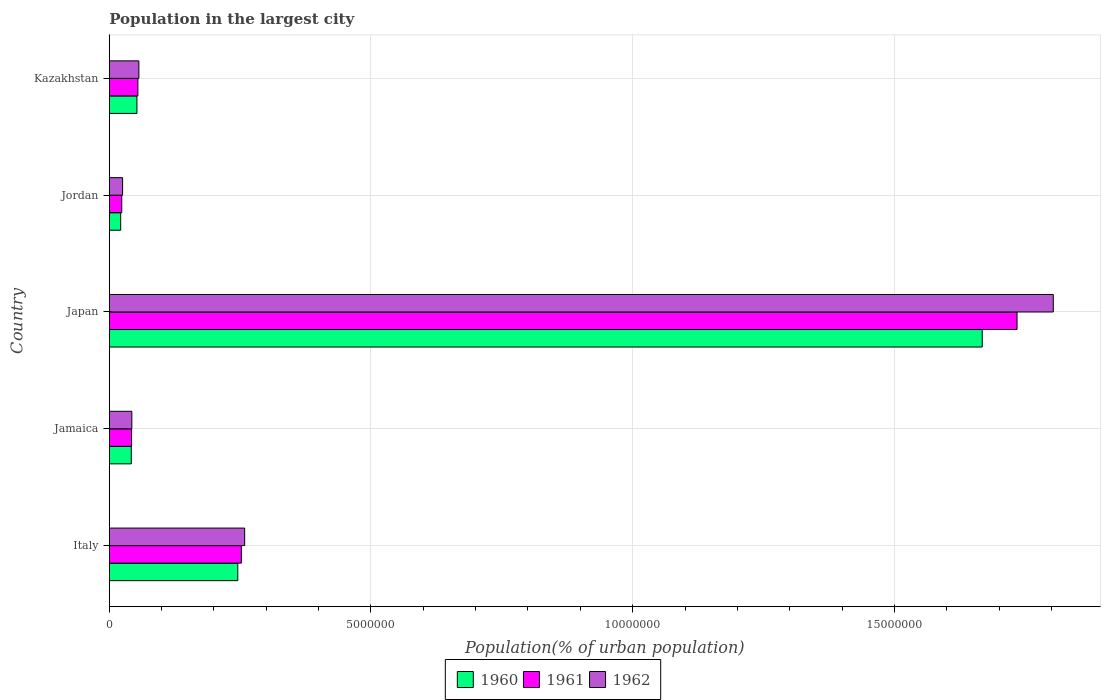How many groups of bars are there?
Give a very brief answer. 5. How many bars are there on the 5th tick from the bottom?
Provide a succinct answer. 3. What is the label of the 1st group of bars from the top?
Your response must be concise. Kazakhstan. What is the population in the largest city in 1961 in Jamaica?
Ensure brevity in your answer.  4.26e+05. Across all countries, what is the maximum population in the largest city in 1961?
Provide a short and direct response. 1.73e+07. Across all countries, what is the minimum population in the largest city in 1962?
Provide a succinct answer. 2.55e+05. In which country was the population in the largest city in 1961 minimum?
Your response must be concise. Jordan. What is the total population in the largest city in 1962 in the graph?
Offer a terse response. 2.19e+07. What is the difference between the population in the largest city in 1960 in Italy and that in Jamaica?
Provide a succinct answer. 2.03e+06. What is the difference between the population in the largest city in 1960 in Italy and the population in the largest city in 1961 in Jordan?
Keep it short and to the point. 2.22e+06. What is the average population in the largest city in 1962 per country?
Make the answer very short. 4.38e+06. What is the difference between the population in the largest city in 1961 and population in the largest city in 1960 in Italy?
Provide a short and direct response. 6.77e+04. In how many countries, is the population in the largest city in 1961 greater than 3000000 %?
Your answer should be very brief. 1. What is the ratio of the population in the largest city in 1962 in Jamaica to that in Jordan?
Your response must be concise. 1.69. Is the population in the largest city in 1962 in Italy less than that in Jordan?
Offer a very short reply. No. Is the difference between the population in the largest city in 1961 in Italy and Kazakhstan greater than the difference between the population in the largest city in 1960 in Italy and Kazakhstan?
Keep it short and to the point. Yes. What is the difference between the highest and the second highest population in the largest city in 1962?
Give a very brief answer. 1.54e+07. What is the difference between the highest and the lowest population in the largest city in 1961?
Offer a terse response. 1.71e+07. Is the sum of the population in the largest city in 1962 in Italy and Jordan greater than the maximum population in the largest city in 1960 across all countries?
Make the answer very short. No. What does the 2nd bar from the top in Japan represents?
Your answer should be very brief. 1961. Are all the bars in the graph horizontal?
Offer a terse response. Yes. Where does the legend appear in the graph?
Provide a short and direct response. Bottom center. How are the legend labels stacked?
Keep it short and to the point. Horizontal. What is the title of the graph?
Give a very brief answer. Population in the largest city. Does "1971" appear as one of the legend labels in the graph?
Provide a succinct answer. No. What is the label or title of the X-axis?
Give a very brief answer. Population(% of urban population). What is the label or title of the Y-axis?
Give a very brief answer. Country. What is the Population(% of urban population) of 1960 in Italy?
Ensure brevity in your answer.  2.46e+06. What is the Population(% of urban population) in 1961 in Italy?
Offer a very short reply. 2.52e+06. What is the Population(% of urban population) in 1962 in Italy?
Your response must be concise. 2.59e+06. What is the Population(% of urban population) of 1960 in Jamaica?
Offer a very short reply. 4.21e+05. What is the Population(% of urban population) in 1961 in Jamaica?
Give a very brief answer. 4.26e+05. What is the Population(% of urban population) in 1962 in Jamaica?
Keep it short and to the point. 4.31e+05. What is the Population(% of urban population) in 1960 in Japan?
Offer a very short reply. 1.67e+07. What is the Population(% of urban population) in 1961 in Japan?
Make the answer very short. 1.73e+07. What is the Population(% of urban population) of 1962 in Japan?
Give a very brief answer. 1.80e+07. What is the Population(% of urban population) in 1960 in Jordan?
Your answer should be compact. 2.18e+05. What is the Population(% of urban population) of 1961 in Jordan?
Your response must be concise. 2.38e+05. What is the Population(% of urban population) in 1962 in Jordan?
Ensure brevity in your answer.  2.55e+05. What is the Population(% of urban population) in 1960 in Kazakhstan?
Your answer should be compact. 5.29e+05. What is the Population(% of urban population) of 1961 in Kazakhstan?
Keep it short and to the point. 5.47e+05. What is the Population(% of urban population) in 1962 in Kazakhstan?
Give a very brief answer. 5.66e+05. Across all countries, what is the maximum Population(% of urban population) of 1960?
Offer a very short reply. 1.67e+07. Across all countries, what is the maximum Population(% of urban population) of 1961?
Keep it short and to the point. 1.73e+07. Across all countries, what is the maximum Population(% of urban population) of 1962?
Ensure brevity in your answer.  1.80e+07. Across all countries, what is the minimum Population(% of urban population) of 1960?
Your response must be concise. 2.18e+05. Across all countries, what is the minimum Population(% of urban population) in 1961?
Your answer should be compact. 2.38e+05. Across all countries, what is the minimum Population(% of urban population) of 1962?
Offer a very short reply. 2.55e+05. What is the total Population(% of urban population) in 1960 in the graph?
Provide a short and direct response. 2.03e+07. What is the total Population(% of urban population) of 1961 in the graph?
Keep it short and to the point. 2.11e+07. What is the total Population(% of urban population) of 1962 in the graph?
Provide a succinct answer. 2.19e+07. What is the difference between the Population(% of urban population) of 1960 in Italy and that in Jamaica?
Ensure brevity in your answer.  2.03e+06. What is the difference between the Population(% of urban population) of 1961 in Italy and that in Jamaica?
Keep it short and to the point. 2.10e+06. What is the difference between the Population(% of urban population) of 1962 in Italy and that in Jamaica?
Your response must be concise. 2.16e+06. What is the difference between the Population(% of urban population) in 1960 in Italy and that in Japan?
Give a very brief answer. -1.42e+07. What is the difference between the Population(% of urban population) of 1961 in Italy and that in Japan?
Ensure brevity in your answer.  -1.48e+07. What is the difference between the Population(% of urban population) of 1962 in Italy and that in Japan?
Keep it short and to the point. -1.54e+07. What is the difference between the Population(% of urban population) in 1960 in Italy and that in Jordan?
Your answer should be very brief. 2.24e+06. What is the difference between the Population(% of urban population) of 1961 in Italy and that in Jordan?
Offer a very short reply. 2.29e+06. What is the difference between the Population(% of urban population) in 1962 in Italy and that in Jordan?
Provide a short and direct response. 2.33e+06. What is the difference between the Population(% of urban population) in 1960 in Italy and that in Kazakhstan?
Your answer should be very brief. 1.93e+06. What is the difference between the Population(% of urban population) of 1961 in Italy and that in Kazakhstan?
Offer a very short reply. 1.98e+06. What is the difference between the Population(% of urban population) of 1962 in Italy and that in Kazakhstan?
Give a very brief answer. 2.02e+06. What is the difference between the Population(% of urban population) of 1960 in Jamaica and that in Japan?
Offer a terse response. -1.63e+07. What is the difference between the Population(% of urban population) of 1961 in Jamaica and that in Japan?
Provide a short and direct response. -1.69e+07. What is the difference between the Population(% of urban population) of 1962 in Jamaica and that in Japan?
Provide a succinct answer. -1.76e+07. What is the difference between the Population(% of urban population) in 1960 in Jamaica and that in Jordan?
Your answer should be very brief. 2.03e+05. What is the difference between the Population(% of urban population) in 1961 in Jamaica and that in Jordan?
Your answer should be very brief. 1.88e+05. What is the difference between the Population(% of urban population) of 1962 in Jamaica and that in Jordan?
Your response must be concise. 1.76e+05. What is the difference between the Population(% of urban population) of 1960 in Jamaica and that in Kazakhstan?
Provide a succinct answer. -1.08e+05. What is the difference between the Population(% of urban population) of 1961 in Jamaica and that in Kazakhstan?
Provide a succinct answer. -1.21e+05. What is the difference between the Population(% of urban population) in 1962 in Jamaica and that in Kazakhstan?
Offer a very short reply. -1.34e+05. What is the difference between the Population(% of urban population) of 1960 in Japan and that in Jordan?
Provide a succinct answer. 1.65e+07. What is the difference between the Population(% of urban population) in 1961 in Japan and that in Jordan?
Your answer should be very brief. 1.71e+07. What is the difference between the Population(% of urban population) in 1962 in Japan and that in Jordan?
Your answer should be compact. 1.78e+07. What is the difference between the Population(% of urban population) of 1960 in Japan and that in Kazakhstan?
Give a very brief answer. 1.62e+07. What is the difference between the Population(% of urban population) of 1961 in Japan and that in Kazakhstan?
Make the answer very short. 1.68e+07. What is the difference between the Population(% of urban population) in 1962 in Japan and that in Kazakhstan?
Keep it short and to the point. 1.75e+07. What is the difference between the Population(% of urban population) in 1960 in Jordan and that in Kazakhstan?
Ensure brevity in your answer.  -3.11e+05. What is the difference between the Population(% of urban population) in 1961 in Jordan and that in Kazakhstan?
Ensure brevity in your answer.  -3.09e+05. What is the difference between the Population(% of urban population) of 1962 in Jordan and that in Kazakhstan?
Provide a succinct answer. -3.11e+05. What is the difference between the Population(% of urban population) of 1960 in Italy and the Population(% of urban population) of 1961 in Jamaica?
Give a very brief answer. 2.03e+06. What is the difference between the Population(% of urban population) in 1960 in Italy and the Population(% of urban population) in 1962 in Jamaica?
Your response must be concise. 2.02e+06. What is the difference between the Population(% of urban population) in 1961 in Italy and the Population(% of urban population) in 1962 in Jamaica?
Your answer should be compact. 2.09e+06. What is the difference between the Population(% of urban population) of 1960 in Italy and the Population(% of urban population) of 1961 in Japan?
Your answer should be very brief. -1.49e+07. What is the difference between the Population(% of urban population) of 1960 in Italy and the Population(% of urban population) of 1962 in Japan?
Your answer should be compact. -1.56e+07. What is the difference between the Population(% of urban population) of 1961 in Italy and the Population(% of urban population) of 1962 in Japan?
Your answer should be compact. -1.55e+07. What is the difference between the Population(% of urban population) of 1960 in Italy and the Population(% of urban population) of 1961 in Jordan?
Make the answer very short. 2.22e+06. What is the difference between the Population(% of urban population) of 1960 in Italy and the Population(% of urban population) of 1962 in Jordan?
Offer a very short reply. 2.20e+06. What is the difference between the Population(% of urban population) of 1961 in Italy and the Population(% of urban population) of 1962 in Jordan?
Ensure brevity in your answer.  2.27e+06. What is the difference between the Population(% of urban population) of 1960 in Italy and the Population(% of urban population) of 1961 in Kazakhstan?
Your answer should be very brief. 1.91e+06. What is the difference between the Population(% of urban population) of 1960 in Italy and the Population(% of urban population) of 1962 in Kazakhstan?
Your answer should be very brief. 1.89e+06. What is the difference between the Population(% of urban population) of 1961 in Italy and the Population(% of urban population) of 1962 in Kazakhstan?
Give a very brief answer. 1.96e+06. What is the difference between the Population(% of urban population) in 1960 in Jamaica and the Population(% of urban population) in 1961 in Japan?
Give a very brief answer. -1.69e+07. What is the difference between the Population(% of urban population) in 1960 in Jamaica and the Population(% of urban population) in 1962 in Japan?
Provide a short and direct response. -1.76e+07. What is the difference between the Population(% of urban population) of 1961 in Jamaica and the Population(% of urban population) of 1962 in Japan?
Provide a succinct answer. -1.76e+07. What is the difference between the Population(% of urban population) in 1960 in Jamaica and the Population(% of urban population) in 1961 in Jordan?
Offer a very short reply. 1.82e+05. What is the difference between the Population(% of urban population) in 1960 in Jamaica and the Population(% of urban population) in 1962 in Jordan?
Offer a terse response. 1.66e+05. What is the difference between the Population(% of urban population) in 1961 in Jamaica and the Population(% of urban population) in 1962 in Jordan?
Offer a very short reply. 1.71e+05. What is the difference between the Population(% of urban population) in 1960 in Jamaica and the Population(% of urban population) in 1961 in Kazakhstan?
Keep it short and to the point. -1.26e+05. What is the difference between the Population(% of urban population) in 1960 in Jamaica and the Population(% of urban population) in 1962 in Kazakhstan?
Ensure brevity in your answer.  -1.45e+05. What is the difference between the Population(% of urban population) in 1961 in Jamaica and the Population(% of urban population) in 1962 in Kazakhstan?
Your response must be concise. -1.40e+05. What is the difference between the Population(% of urban population) of 1960 in Japan and the Population(% of urban population) of 1961 in Jordan?
Your answer should be very brief. 1.64e+07. What is the difference between the Population(% of urban population) in 1960 in Japan and the Population(% of urban population) in 1962 in Jordan?
Your answer should be very brief. 1.64e+07. What is the difference between the Population(% of urban population) of 1961 in Japan and the Population(% of urban population) of 1962 in Jordan?
Ensure brevity in your answer.  1.71e+07. What is the difference between the Population(% of urban population) of 1960 in Japan and the Population(% of urban population) of 1961 in Kazakhstan?
Offer a very short reply. 1.61e+07. What is the difference between the Population(% of urban population) in 1960 in Japan and the Population(% of urban population) in 1962 in Kazakhstan?
Ensure brevity in your answer.  1.61e+07. What is the difference between the Population(% of urban population) of 1961 in Japan and the Population(% of urban population) of 1962 in Kazakhstan?
Provide a short and direct response. 1.68e+07. What is the difference between the Population(% of urban population) in 1960 in Jordan and the Population(% of urban population) in 1961 in Kazakhstan?
Provide a succinct answer. -3.29e+05. What is the difference between the Population(% of urban population) in 1960 in Jordan and the Population(% of urban population) in 1962 in Kazakhstan?
Offer a very short reply. -3.48e+05. What is the difference between the Population(% of urban population) in 1961 in Jordan and the Population(% of urban population) in 1962 in Kazakhstan?
Your answer should be compact. -3.27e+05. What is the average Population(% of urban population) of 1960 per country?
Your response must be concise. 4.06e+06. What is the average Population(% of urban population) in 1961 per country?
Keep it short and to the point. 4.22e+06. What is the average Population(% of urban population) of 1962 per country?
Provide a succinct answer. 4.38e+06. What is the difference between the Population(% of urban population) in 1960 and Population(% of urban population) in 1961 in Italy?
Your answer should be compact. -6.77e+04. What is the difference between the Population(% of urban population) of 1960 and Population(% of urban population) of 1962 in Italy?
Your answer should be compact. -1.31e+05. What is the difference between the Population(% of urban population) in 1961 and Population(% of urban population) in 1962 in Italy?
Your response must be concise. -6.37e+04. What is the difference between the Population(% of urban population) in 1960 and Population(% of urban population) in 1961 in Jamaica?
Provide a succinct answer. -5262. What is the difference between the Population(% of urban population) in 1960 and Population(% of urban population) in 1962 in Jamaica?
Your response must be concise. -1.06e+04. What is the difference between the Population(% of urban population) in 1961 and Population(% of urban population) in 1962 in Jamaica?
Ensure brevity in your answer.  -5334. What is the difference between the Population(% of urban population) of 1960 and Population(% of urban population) of 1961 in Japan?
Give a very brief answer. -6.65e+05. What is the difference between the Population(% of urban population) of 1960 and Population(% of urban population) of 1962 in Japan?
Ensure brevity in your answer.  -1.36e+06. What is the difference between the Population(% of urban population) in 1961 and Population(% of urban population) in 1962 in Japan?
Offer a terse response. -6.93e+05. What is the difference between the Population(% of urban population) in 1960 and Population(% of urban population) in 1961 in Jordan?
Offer a terse response. -2.01e+04. What is the difference between the Population(% of urban population) in 1960 and Population(% of urban population) in 1962 in Jordan?
Offer a very short reply. -3.67e+04. What is the difference between the Population(% of urban population) of 1961 and Population(% of urban population) of 1962 in Jordan?
Offer a very short reply. -1.65e+04. What is the difference between the Population(% of urban population) in 1960 and Population(% of urban population) in 1961 in Kazakhstan?
Provide a succinct answer. -1.82e+04. What is the difference between the Population(% of urban population) in 1960 and Population(% of urban population) in 1962 in Kazakhstan?
Your answer should be very brief. -3.70e+04. What is the difference between the Population(% of urban population) in 1961 and Population(% of urban population) in 1962 in Kazakhstan?
Your response must be concise. -1.88e+04. What is the ratio of the Population(% of urban population) of 1960 in Italy to that in Jamaica?
Offer a terse response. 5.84. What is the ratio of the Population(% of urban population) in 1961 in Italy to that in Jamaica?
Your answer should be compact. 5.92. What is the ratio of the Population(% of urban population) in 1962 in Italy to that in Jamaica?
Your answer should be very brief. 6. What is the ratio of the Population(% of urban population) in 1960 in Italy to that in Japan?
Your response must be concise. 0.15. What is the ratio of the Population(% of urban population) in 1961 in Italy to that in Japan?
Offer a terse response. 0.15. What is the ratio of the Population(% of urban population) of 1962 in Italy to that in Japan?
Give a very brief answer. 0.14. What is the ratio of the Population(% of urban population) of 1960 in Italy to that in Jordan?
Offer a very short reply. 11.26. What is the ratio of the Population(% of urban population) of 1961 in Italy to that in Jordan?
Your answer should be very brief. 10.59. What is the ratio of the Population(% of urban population) of 1962 in Italy to that in Jordan?
Keep it short and to the point. 10.15. What is the ratio of the Population(% of urban population) of 1960 in Italy to that in Kazakhstan?
Offer a terse response. 4.64. What is the ratio of the Population(% of urban population) of 1961 in Italy to that in Kazakhstan?
Your response must be concise. 4.61. What is the ratio of the Population(% of urban population) of 1962 in Italy to that in Kazakhstan?
Your response must be concise. 4.57. What is the ratio of the Population(% of urban population) in 1960 in Jamaica to that in Japan?
Offer a terse response. 0.03. What is the ratio of the Population(% of urban population) of 1961 in Jamaica to that in Japan?
Provide a short and direct response. 0.02. What is the ratio of the Population(% of urban population) of 1962 in Jamaica to that in Japan?
Offer a very short reply. 0.02. What is the ratio of the Population(% of urban population) of 1960 in Jamaica to that in Jordan?
Keep it short and to the point. 1.93. What is the ratio of the Population(% of urban population) of 1961 in Jamaica to that in Jordan?
Provide a succinct answer. 1.79. What is the ratio of the Population(% of urban population) in 1962 in Jamaica to that in Jordan?
Provide a succinct answer. 1.69. What is the ratio of the Population(% of urban population) of 1960 in Jamaica to that in Kazakhstan?
Provide a short and direct response. 0.8. What is the ratio of the Population(% of urban population) in 1961 in Jamaica to that in Kazakhstan?
Your answer should be very brief. 0.78. What is the ratio of the Population(% of urban population) of 1962 in Jamaica to that in Kazakhstan?
Keep it short and to the point. 0.76. What is the ratio of the Population(% of urban population) in 1960 in Japan to that in Jordan?
Ensure brevity in your answer.  76.47. What is the ratio of the Population(% of urban population) in 1961 in Japan to that in Jordan?
Offer a very short reply. 72.8. What is the ratio of the Population(% of urban population) of 1962 in Japan to that in Jordan?
Make the answer very short. 70.8. What is the ratio of the Population(% of urban population) in 1960 in Japan to that in Kazakhstan?
Provide a short and direct response. 31.55. What is the ratio of the Population(% of urban population) of 1961 in Japan to that in Kazakhstan?
Your answer should be very brief. 31.72. What is the ratio of the Population(% of urban population) of 1962 in Japan to that in Kazakhstan?
Your answer should be very brief. 31.89. What is the ratio of the Population(% of urban population) in 1960 in Jordan to that in Kazakhstan?
Make the answer very short. 0.41. What is the ratio of the Population(% of urban population) of 1961 in Jordan to that in Kazakhstan?
Ensure brevity in your answer.  0.44. What is the ratio of the Population(% of urban population) of 1962 in Jordan to that in Kazakhstan?
Offer a terse response. 0.45. What is the difference between the highest and the second highest Population(% of urban population) in 1960?
Keep it short and to the point. 1.42e+07. What is the difference between the highest and the second highest Population(% of urban population) in 1961?
Offer a very short reply. 1.48e+07. What is the difference between the highest and the second highest Population(% of urban population) of 1962?
Ensure brevity in your answer.  1.54e+07. What is the difference between the highest and the lowest Population(% of urban population) of 1960?
Keep it short and to the point. 1.65e+07. What is the difference between the highest and the lowest Population(% of urban population) of 1961?
Provide a short and direct response. 1.71e+07. What is the difference between the highest and the lowest Population(% of urban population) of 1962?
Ensure brevity in your answer.  1.78e+07. 